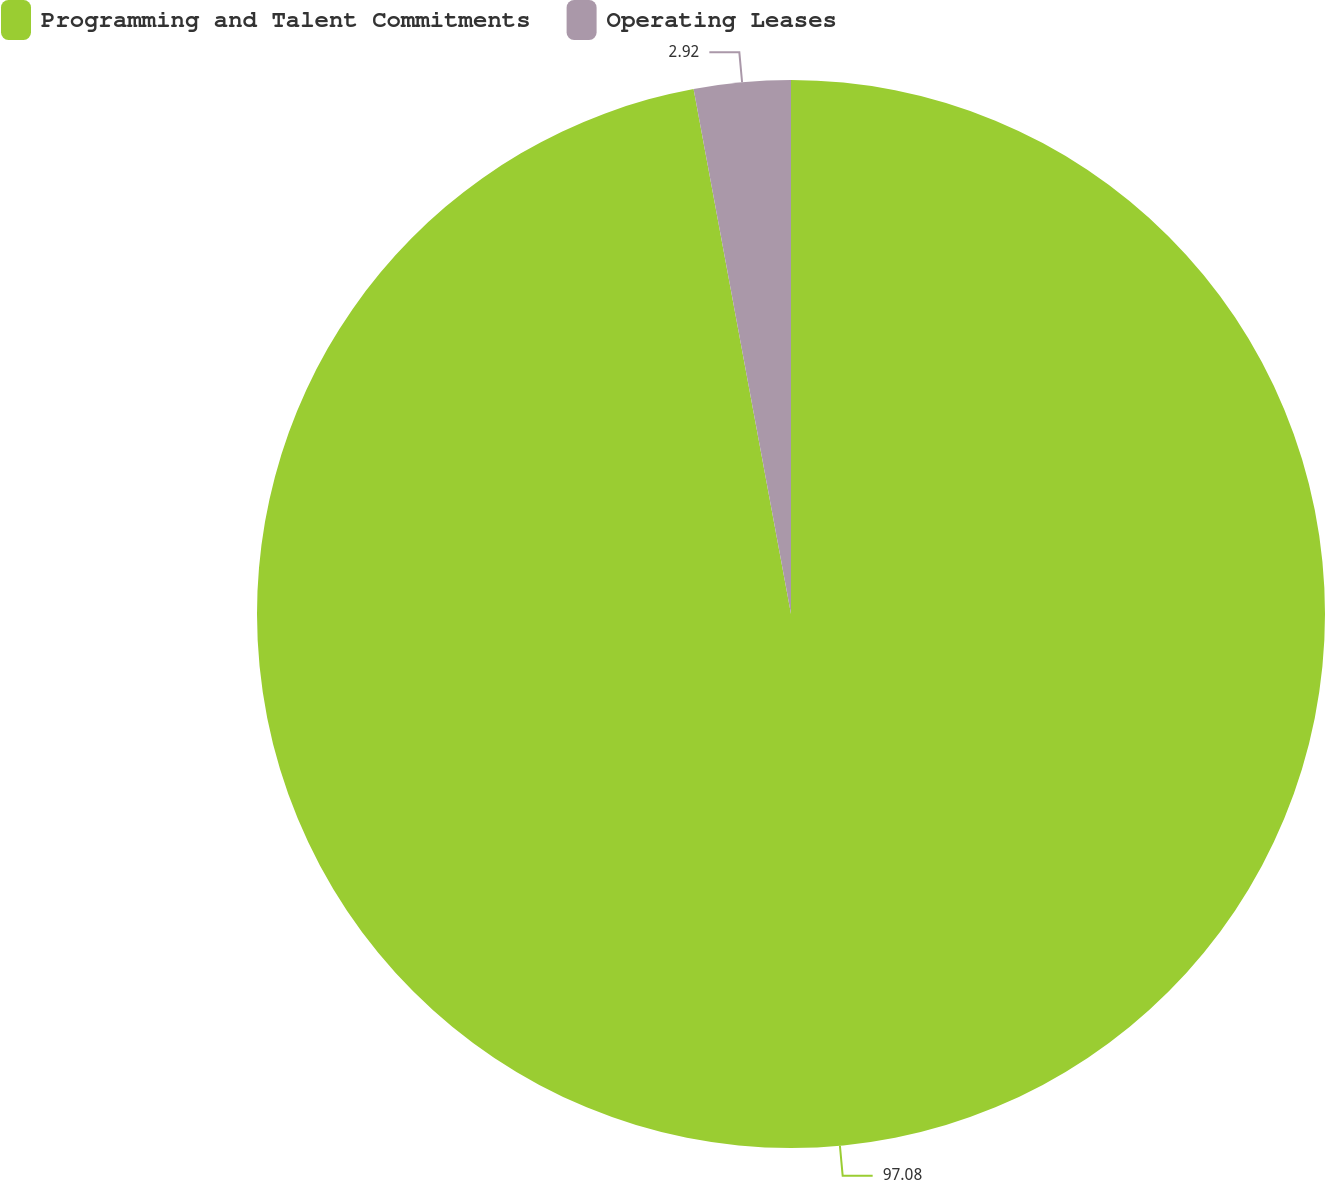Convert chart. <chart><loc_0><loc_0><loc_500><loc_500><pie_chart><fcel>Programming and Talent Commitments<fcel>Operating Leases<nl><fcel>97.08%<fcel>2.92%<nl></chart> 